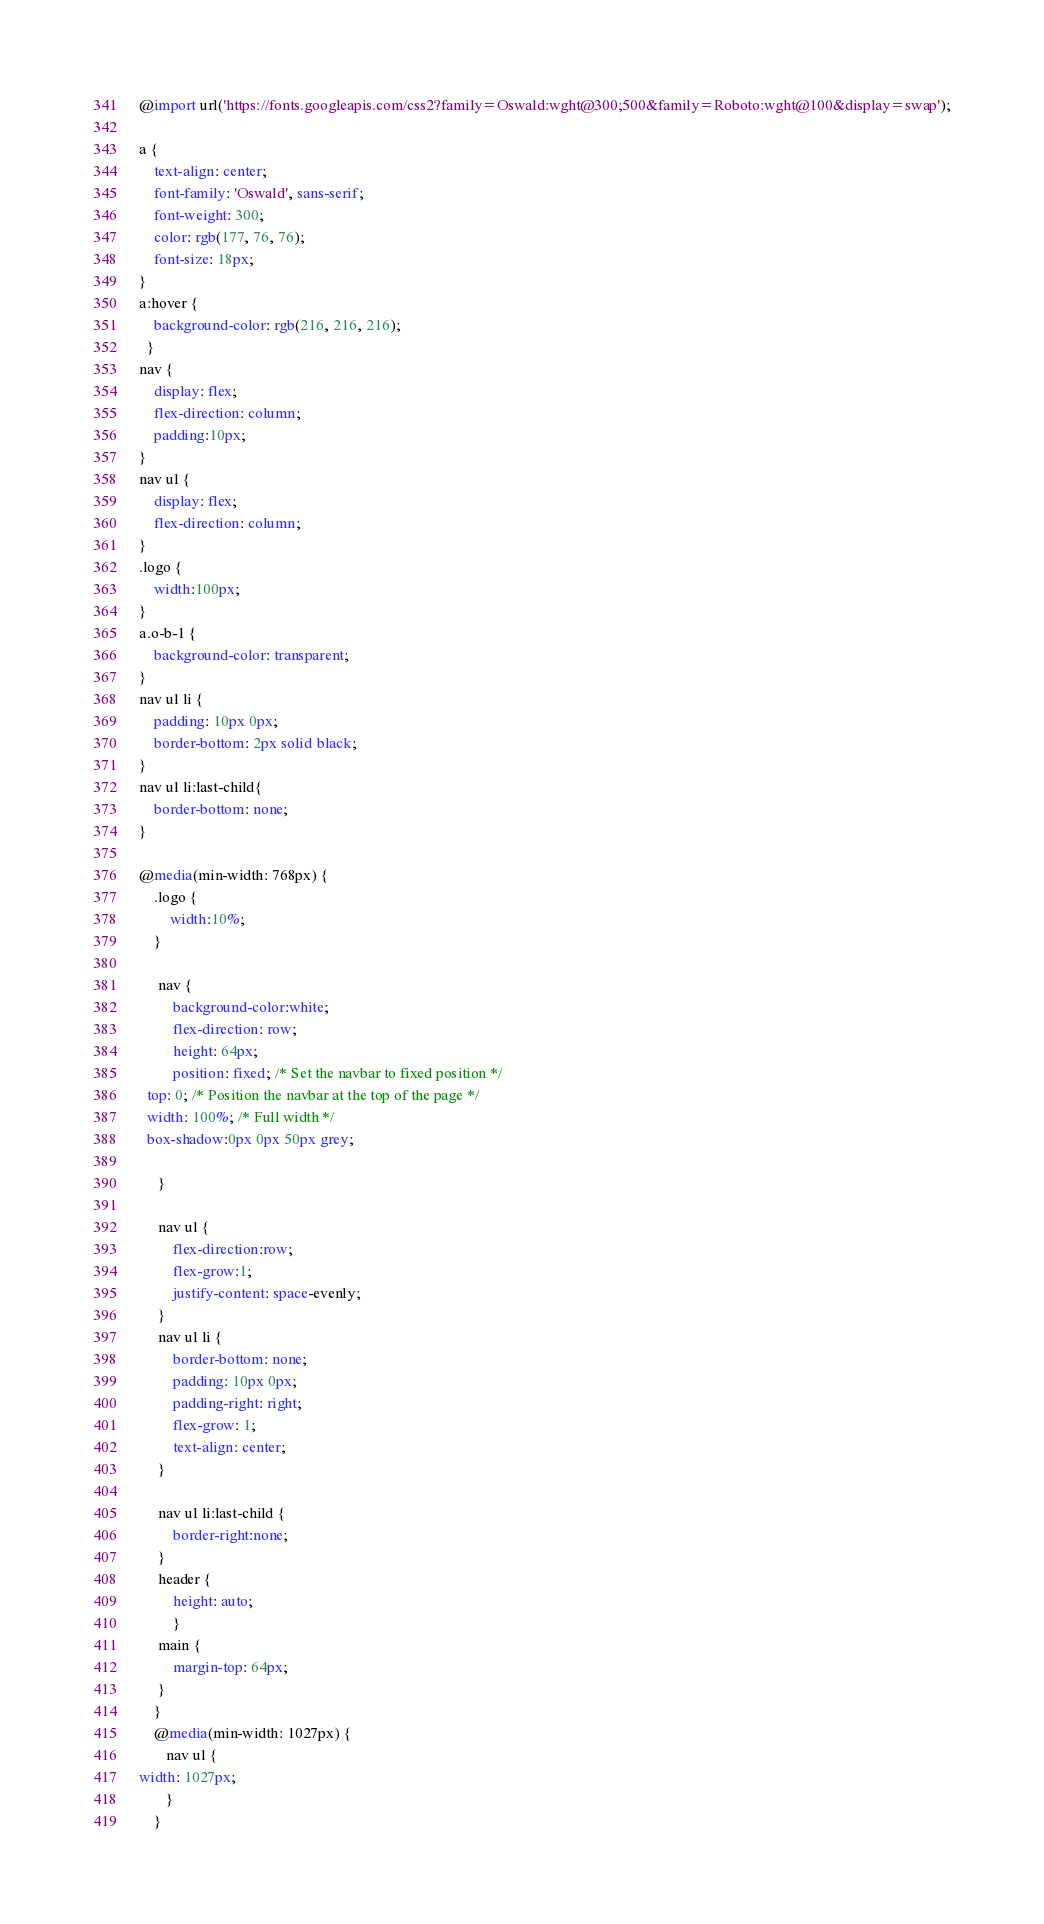Convert code to text. <code><loc_0><loc_0><loc_500><loc_500><_CSS_>@import url('https://fonts.googleapis.com/css2?family=Oswald:wght@300;500&family=Roboto:wght@100&display=swap');

a {
    text-align: center;
    font-family: 'Oswald', sans-serif;
    font-weight: 300;
    color: rgb(177, 76, 76);
    font-size: 18px;
}
a:hover {
    background-color: rgb(216, 216, 216);
  }
nav {
    display: flex;
    flex-direction: column;
    padding:10px;
}
nav ul {
    display: flex;
    flex-direction: column;
}
.logo {
    width:100px;
}
a.o-b-1 {
    background-color: transparent;
}
nav ul li {
    padding: 10px 0px;
    border-bottom: 2px solid black;
}
nav ul li:last-child{
    border-bottom: none;
}

@media(min-width: 768px) {
    .logo {
        width:10%;
    }

     nav {
         background-color:white;
         flex-direction: row;
         height: 64px;
         position: fixed; /* Set the navbar to fixed position */
  top: 0; /* Position the navbar at the top of the page */
  width: 100%; /* Full width */
  box-shadow:0px 0px 50px grey; 
  
     }
     
     nav ul {
         flex-direction:row;
         flex-grow:1;
         justify-content: space-evenly;
     }
     nav ul li {
         border-bottom: none; 
         padding: 10px 0px;   
         padding-right: right;
         flex-grow: 1;
         text-align: center;
     }
     
     nav ul li:last-child {
         border-right:none;
     }
     header {
         height: auto;
         }
     main {
         margin-top: 64px;
     }
    }
    @media(min-width: 1027px) {
       nav ul {
width: 1027px;
       } 
    }</code> 